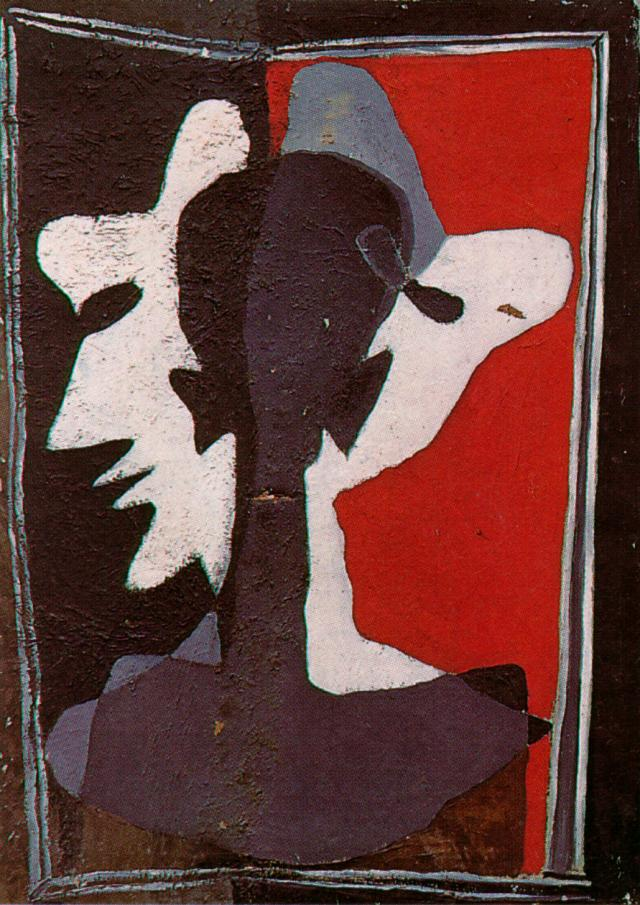What emotions do you think this image conveys? The overlapping faces and stark contrast of colors in this image evoke a range of emotions, from tension and conflict to a sense of silent communication. The red background might suggest passion or anger, while the black and white forms could symbolize opposing forces or dualities within the self. Overall, the visual tension and layered textures create an emotionally charged atmosphere open to interpretation. 